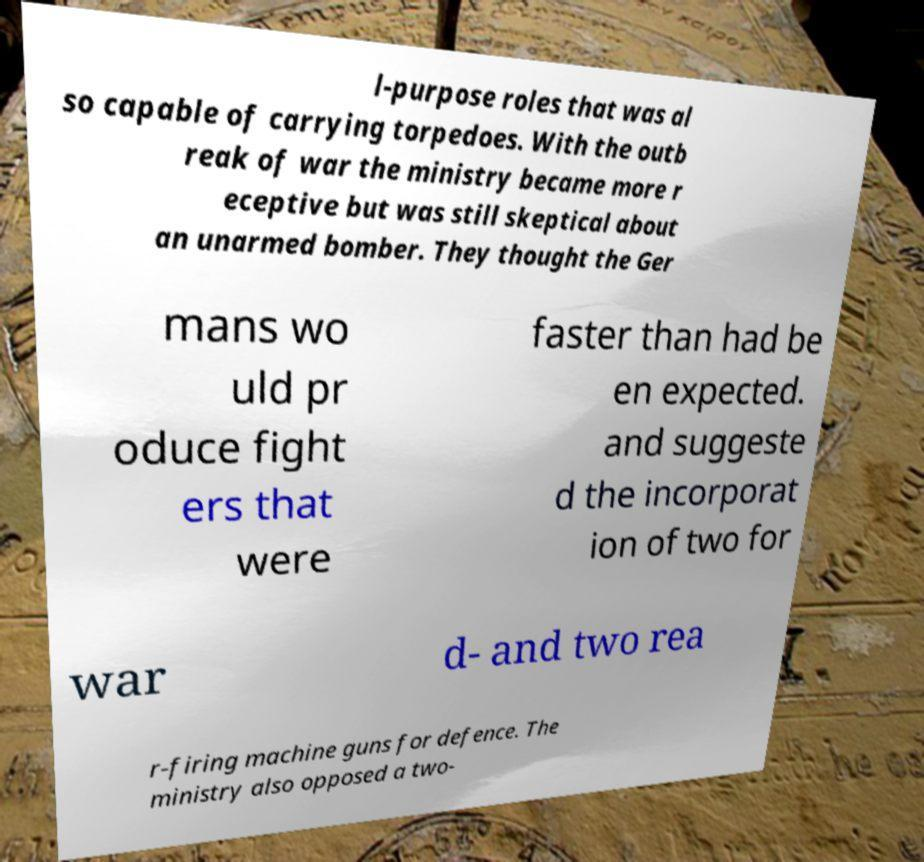Can you read and provide the text displayed in the image?This photo seems to have some interesting text. Can you extract and type it out for me? l-purpose roles that was al so capable of carrying torpedoes. With the outb reak of war the ministry became more r eceptive but was still skeptical about an unarmed bomber. They thought the Ger mans wo uld pr oduce fight ers that were faster than had be en expected. and suggeste d the incorporat ion of two for war d- and two rea r-firing machine guns for defence. The ministry also opposed a two- 